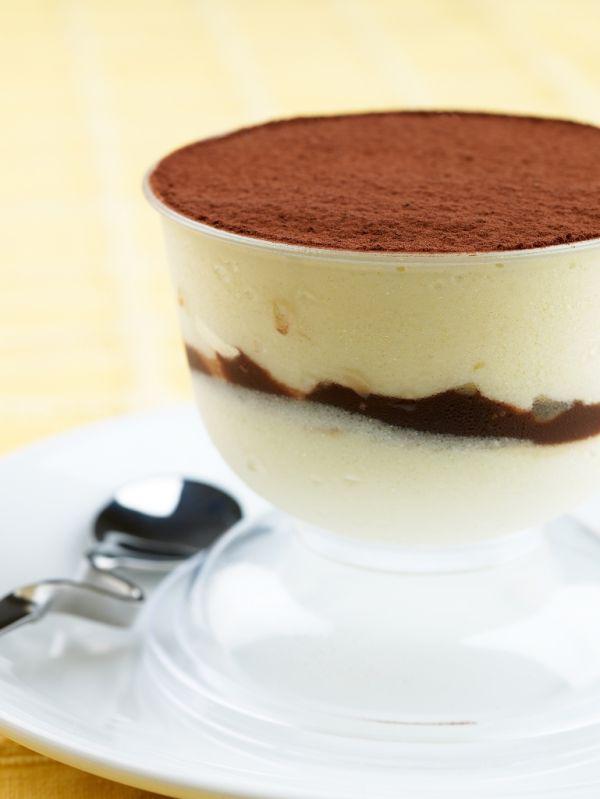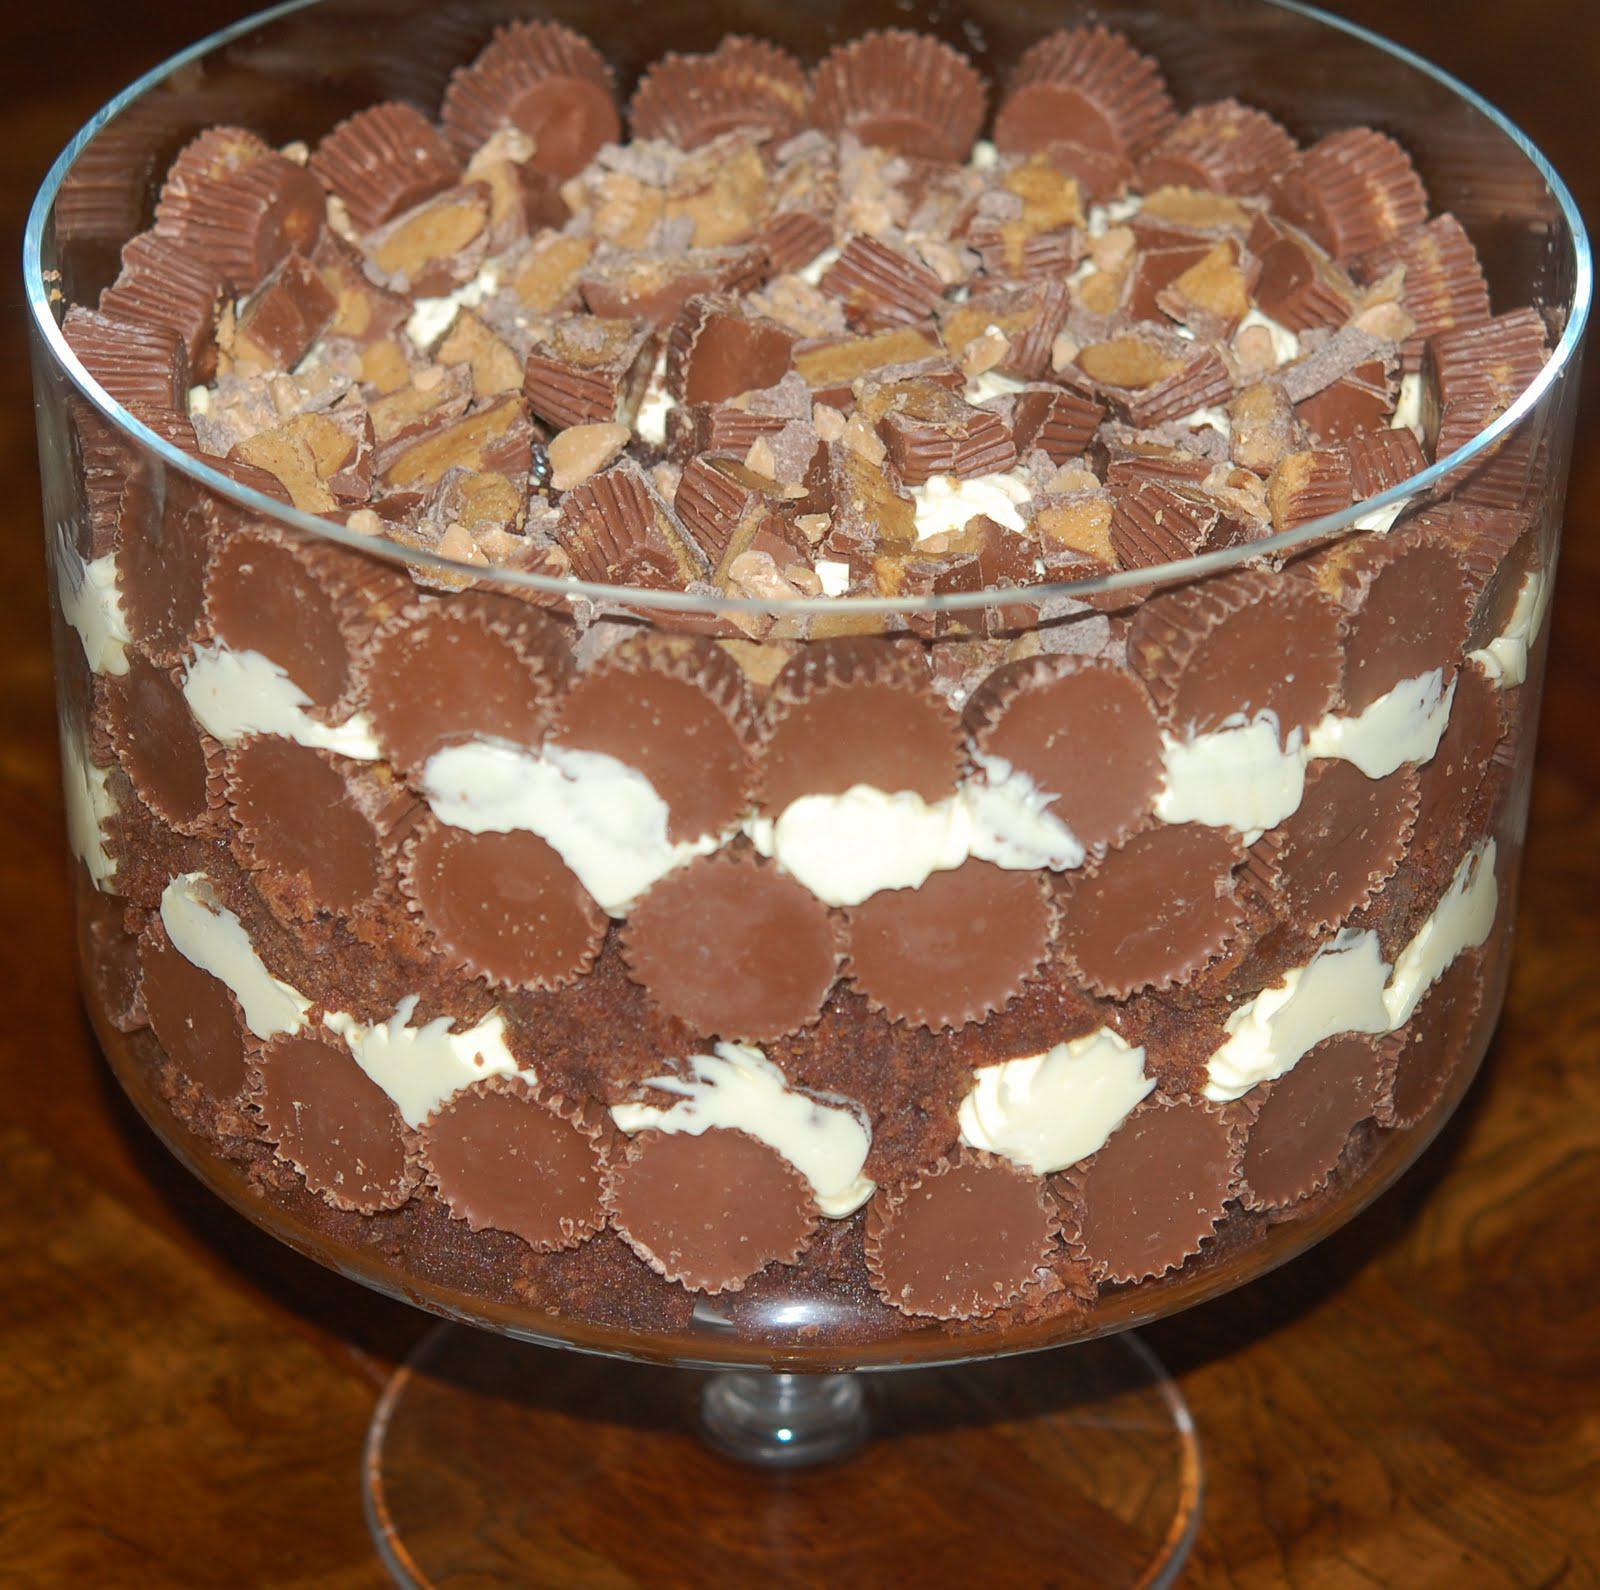The first image is the image on the left, the second image is the image on the right. Considering the images on both sides, is "An image shows a creamy layered dessert with one row of brown shapes arranged inside the glass of the footed serving bowl." valid? Answer yes or no. No. The first image is the image on the left, the second image is the image on the right. Evaluate the accuracy of this statement regarding the images: "In one image, a large creamy dessert is displayed in a clear footed bowl, while a second image shows at least one individual dessert with the same number of spoons.". Is it true? Answer yes or no. No. 